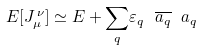<formula> <loc_0><loc_0><loc_500><loc_500>E [ J _ { \mu } ^ { \, \nu } ] \simeq E + \underset { q } { \sum } \varepsilon _ { q } \ \overline { a _ { q } } \ a _ { q }</formula> 